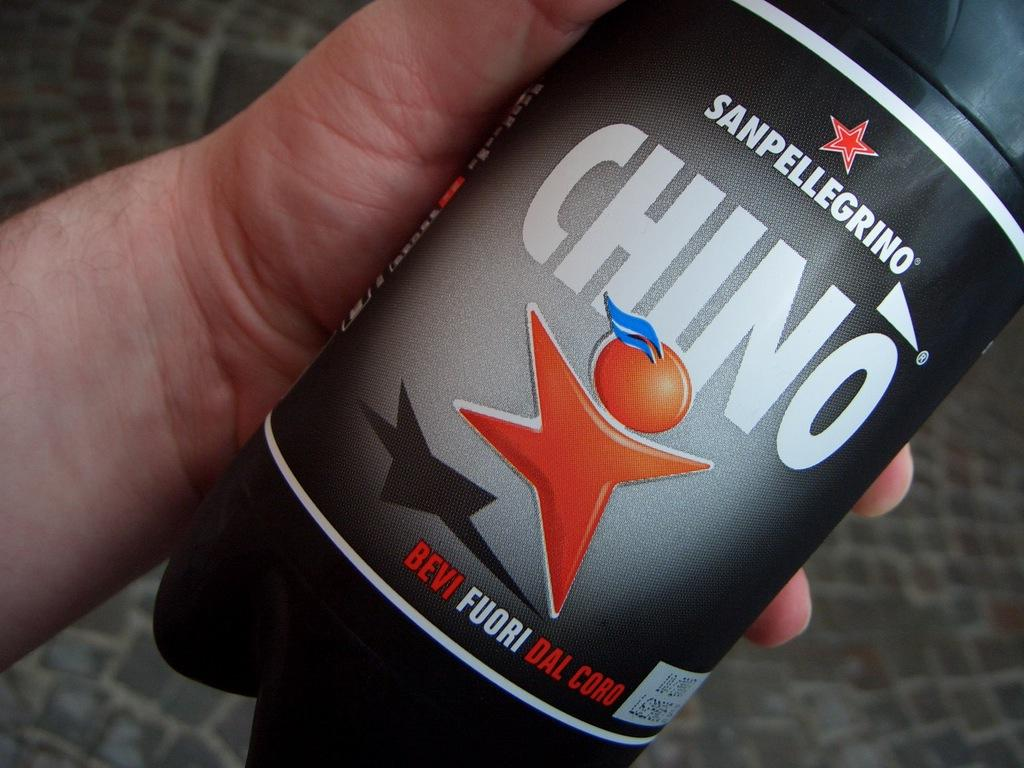<image>
Create a compact narrative representing the image presented. A hand is holding a black bottle of Sanpellegrino. 